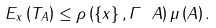Convert formula to latex. <formula><loc_0><loc_0><loc_500><loc_500>E _ { x } \left ( T _ { A } \right ) \leq \rho \left ( \left \{ x \right \} , \Gamma \ A \right ) \mu \left ( A \right ) .</formula> 